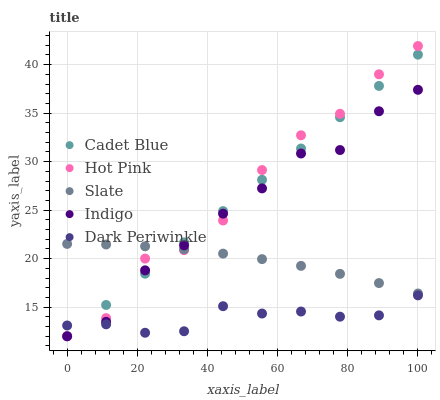Does Dark Periwinkle have the minimum area under the curve?
Answer yes or no. Yes. Does Hot Pink have the maximum area under the curve?
Answer yes or no. Yes. Does Cadet Blue have the minimum area under the curve?
Answer yes or no. No. Does Cadet Blue have the maximum area under the curve?
Answer yes or no. No. Is Cadet Blue the smoothest?
Answer yes or no. Yes. Is Hot Pink the roughest?
Answer yes or no. Yes. Is Indigo the smoothest?
Answer yes or no. No. Is Indigo the roughest?
Answer yes or no. No. Does Cadet Blue have the lowest value?
Answer yes or no. Yes. Does Dark Periwinkle have the lowest value?
Answer yes or no. No. Does Hot Pink have the highest value?
Answer yes or no. Yes. Does Cadet Blue have the highest value?
Answer yes or no. No. Is Dark Periwinkle less than Slate?
Answer yes or no. Yes. Is Slate greater than Dark Periwinkle?
Answer yes or no. Yes. Does Dark Periwinkle intersect Cadet Blue?
Answer yes or no. Yes. Is Dark Periwinkle less than Cadet Blue?
Answer yes or no. No. Is Dark Periwinkle greater than Cadet Blue?
Answer yes or no. No. Does Dark Periwinkle intersect Slate?
Answer yes or no. No. 